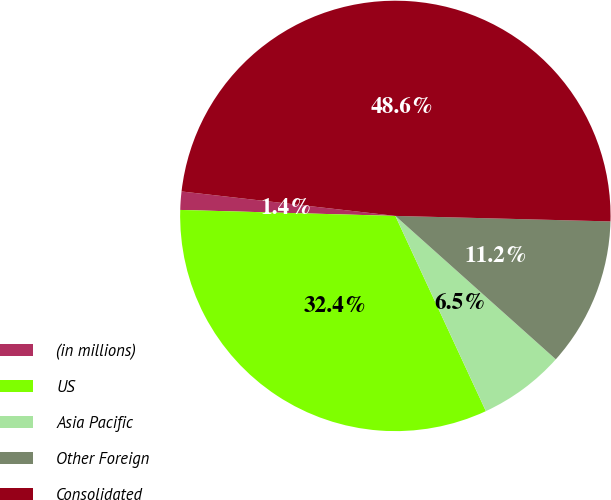Convert chart. <chart><loc_0><loc_0><loc_500><loc_500><pie_chart><fcel>(in millions)<fcel>US<fcel>Asia Pacific<fcel>Other Foreign<fcel>Consolidated<nl><fcel>1.37%<fcel>32.35%<fcel>6.48%<fcel>11.2%<fcel>48.59%<nl></chart> 